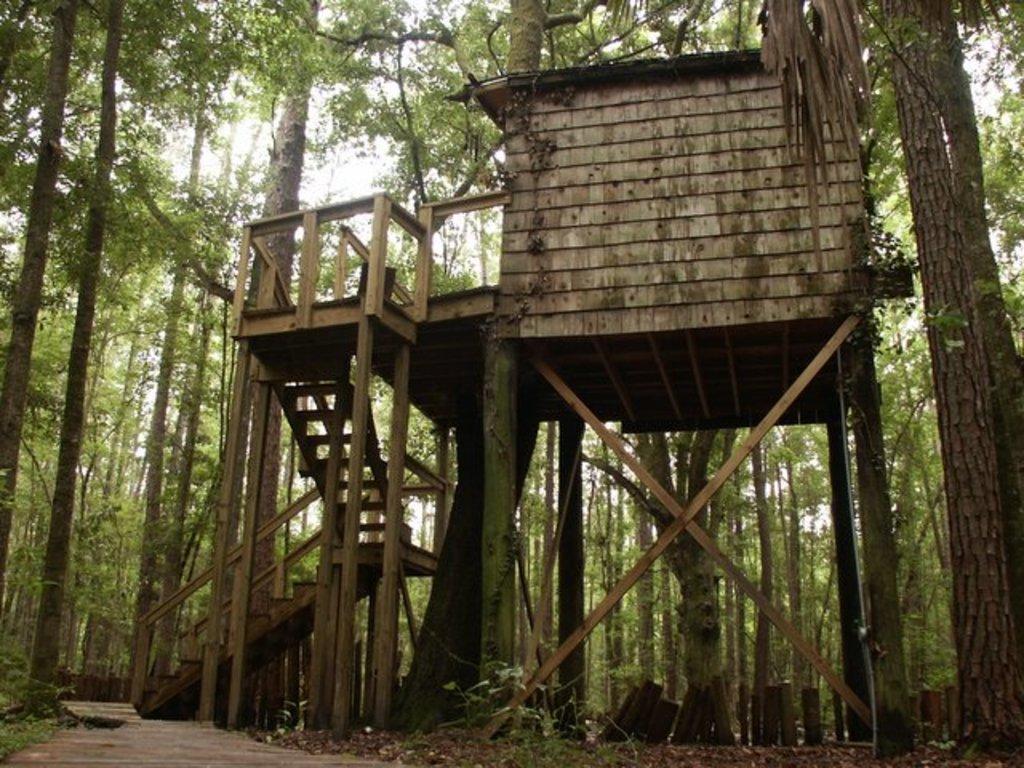How would you summarize this image in a sentence or two? In front of the image there is a tree house with wooden stairs and wooden fence, around the house there are trees. 